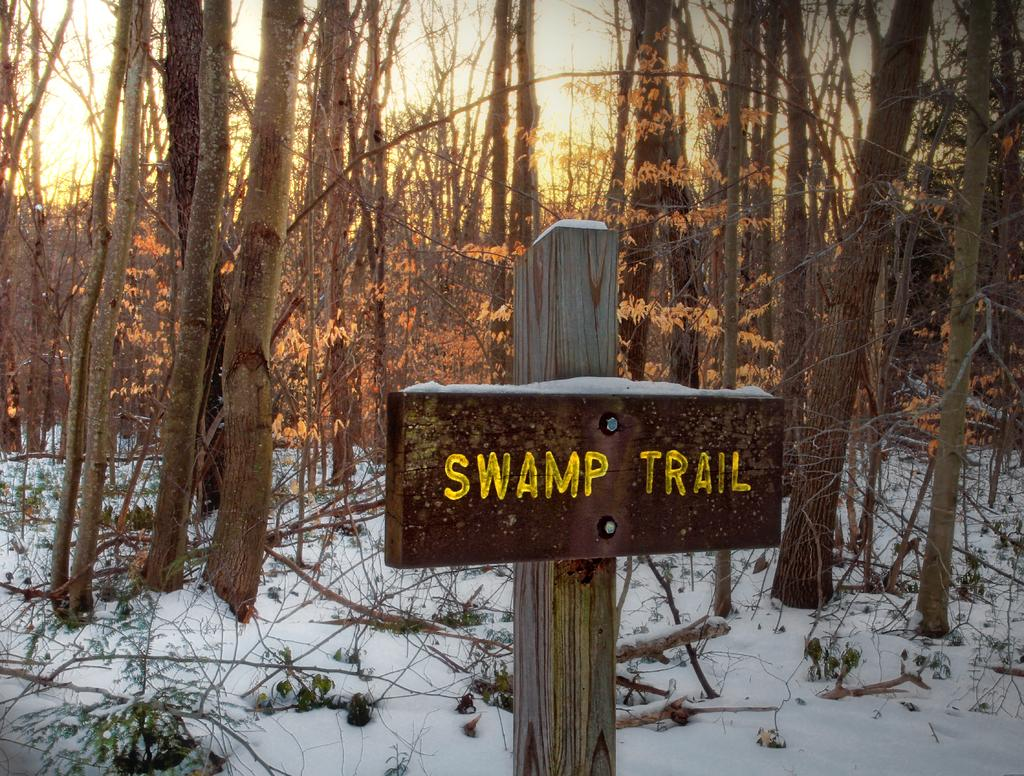What is attached to the wooden pole in the image? There is a board attached to a wooden pole in the image. What is the weather like in the image? There is snow visible in the image, indicating a cold and likely wintery scene. What can be seen in the background of the image? There are trees in the background of the image. What type of alarm can be heard going off in the image? There is no alarm present in the image, and therefore no sound can be heard. 